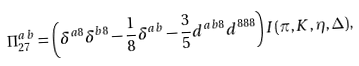<formula> <loc_0><loc_0><loc_500><loc_500>\Pi ^ { a b } _ { 2 7 } = \left ( \delta ^ { a 8 } \delta ^ { b 8 } - \frac { 1 } { 8 } \delta ^ { a b } - \frac { 3 } { 5 } d ^ { a b 8 } d ^ { 8 8 8 } \right ) I ( \pi , K , \eta , \Delta ) ,</formula> 